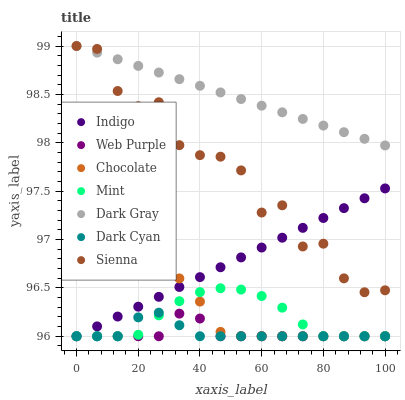Does Web Purple have the minimum area under the curve?
Answer yes or no. Yes. Does Dark Gray have the maximum area under the curve?
Answer yes or no. Yes. Does Indigo have the minimum area under the curve?
Answer yes or no. No. Does Indigo have the maximum area under the curve?
Answer yes or no. No. Is Indigo the smoothest?
Answer yes or no. Yes. Is Sienna the roughest?
Answer yes or no. Yes. Is Chocolate the smoothest?
Answer yes or no. No. Is Chocolate the roughest?
Answer yes or no. No. Does Indigo have the lowest value?
Answer yes or no. Yes. Does Dark Gray have the lowest value?
Answer yes or no. No. Does Dark Gray have the highest value?
Answer yes or no. Yes. Does Indigo have the highest value?
Answer yes or no. No. Is Mint less than Dark Gray?
Answer yes or no. Yes. Is Dark Gray greater than Web Purple?
Answer yes or no. Yes. Does Dark Cyan intersect Chocolate?
Answer yes or no. Yes. Is Dark Cyan less than Chocolate?
Answer yes or no. No. Is Dark Cyan greater than Chocolate?
Answer yes or no. No. Does Mint intersect Dark Gray?
Answer yes or no. No. 